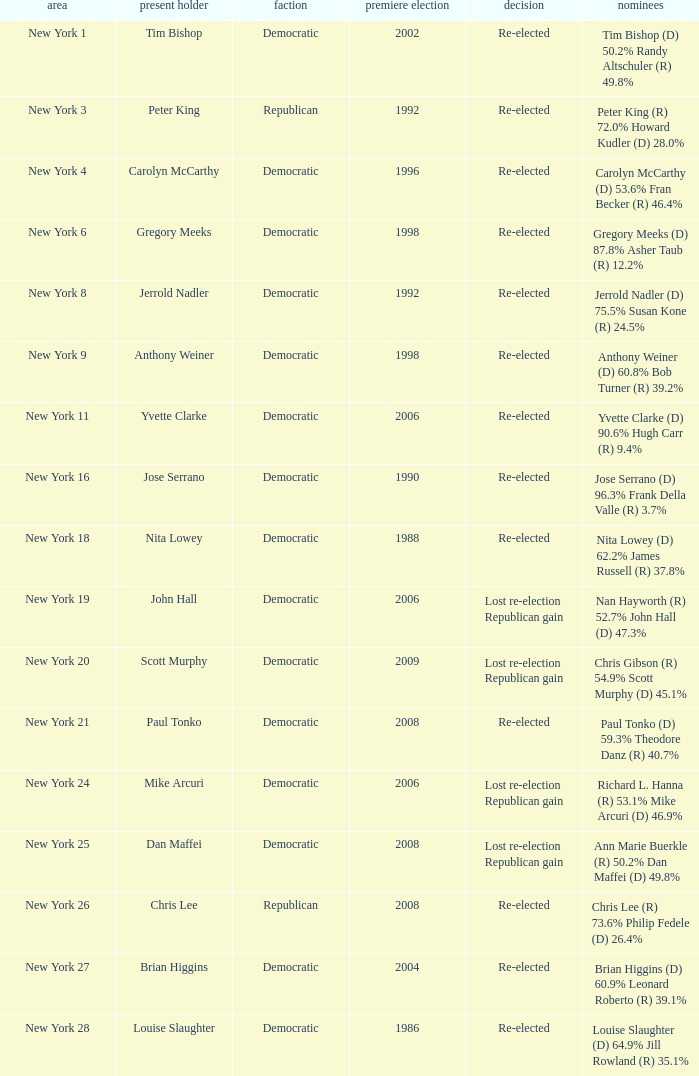Name the party for new york 4 Democratic. 